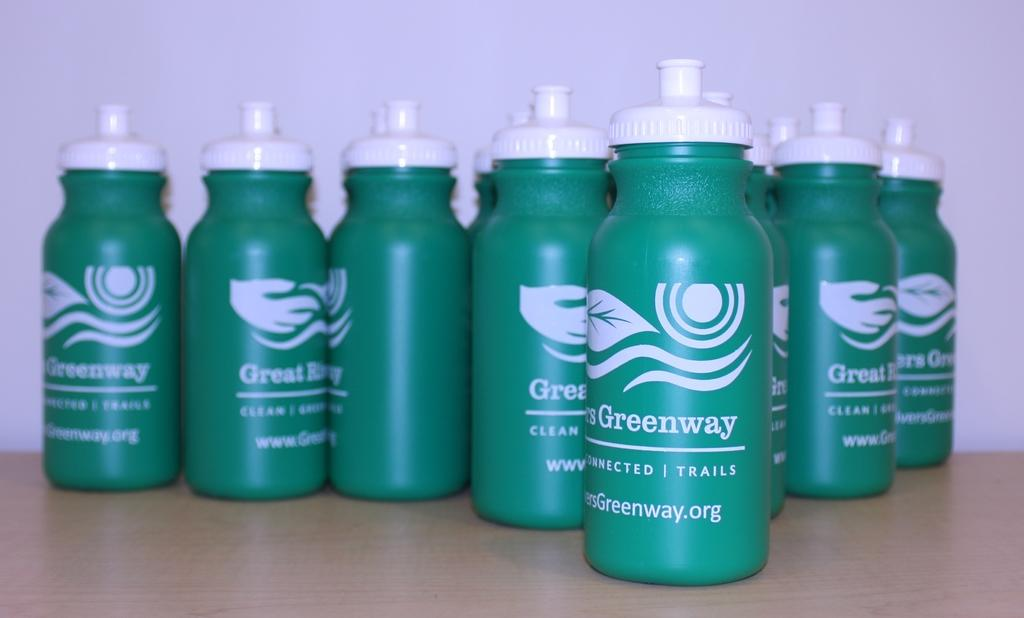<image>
Offer a succinct explanation of the picture presented. Green bottles with Greenway written on the front in white. 